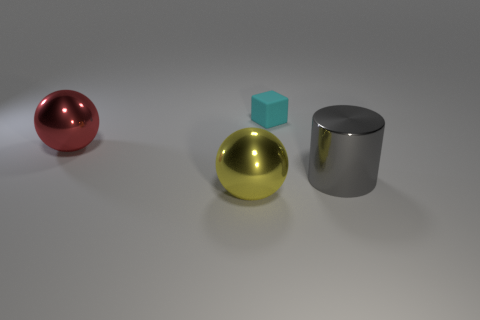Add 2 big green shiny cubes. How many objects exist? 6 Add 2 matte things. How many matte things are left? 3 Add 4 small cyan objects. How many small cyan objects exist? 5 Subtract 0 brown cylinders. How many objects are left? 4 Subtract all purple balls. Subtract all green cylinders. How many balls are left? 2 Subtract all big red objects. Subtract all matte blocks. How many objects are left? 2 